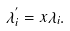Convert formula to latex. <formula><loc_0><loc_0><loc_500><loc_500>\lambda ^ { ^ { \prime } } _ { i } = x \lambda _ { i } .</formula> 